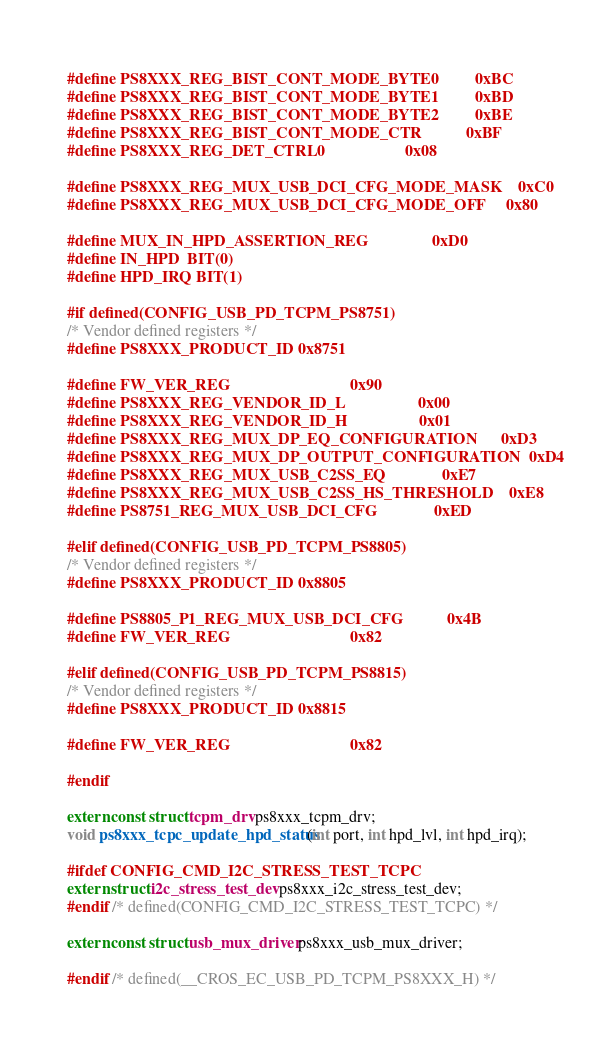<code> <loc_0><loc_0><loc_500><loc_500><_C_>#define PS8XXX_REG_BIST_CONT_MODE_BYTE0         0xBC
#define PS8XXX_REG_BIST_CONT_MODE_BYTE1         0xBD
#define PS8XXX_REG_BIST_CONT_MODE_BYTE2         0xBE
#define PS8XXX_REG_BIST_CONT_MODE_CTR           0xBF
#define PS8XXX_REG_DET_CTRL0                    0x08

#define PS8XXX_REG_MUX_USB_DCI_CFG_MODE_MASK    0xC0
#define PS8XXX_REG_MUX_USB_DCI_CFG_MODE_OFF     0x80

#define MUX_IN_HPD_ASSERTION_REG                0xD0
#define IN_HPD  BIT(0)
#define HPD_IRQ BIT(1)

#if defined(CONFIG_USB_PD_TCPM_PS8751)
/* Vendor defined registers */
#define PS8XXX_PRODUCT_ID 0x8751

#define FW_VER_REG                              0x90
#define PS8XXX_REG_VENDOR_ID_L                  0x00
#define PS8XXX_REG_VENDOR_ID_H                  0x01
#define PS8XXX_REG_MUX_DP_EQ_CONFIGURATION      0xD3
#define PS8XXX_REG_MUX_DP_OUTPUT_CONFIGURATION  0xD4
#define PS8XXX_REG_MUX_USB_C2SS_EQ              0xE7
#define PS8XXX_REG_MUX_USB_C2SS_HS_THRESHOLD    0xE8
#define PS8751_REG_MUX_USB_DCI_CFG              0xED

#elif defined(CONFIG_USB_PD_TCPM_PS8805)
/* Vendor defined registers */
#define PS8XXX_PRODUCT_ID 0x8805

#define PS8805_P1_REG_MUX_USB_DCI_CFG           0x4B
#define FW_VER_REG                              0x82

#elif defined(CONFIG_USB_PD_TCPM_PS8815)
/* Vendor defined registers */
#define PS8XXX_PRODUCT_ID 0x8815

#define FW_VER_REG                              0x82

#endif

extern const struct tcpm_drv ps8xxx_tcpm_drv;
void ps8xxx_tcpc_update_hpd_status(int port, int hpd_lvl, int hpd_irq);

#ifdef CONFIG_CMD_I2C_STRESS_TEST_TCPC
extern struct i2c_stress_test_dev ps8xxx_i2c_stress_test_dev;
#endif /* defined(CONFIG_CMD_I2C_STRESS_TEST_TCPC) */

extern const struct usb_mux_driver ps8xxx_usb_mux_driver;

#endif /* defined(__CROS_EC_USB_PD_TCPM_PS8XXX_H) */
</code> 